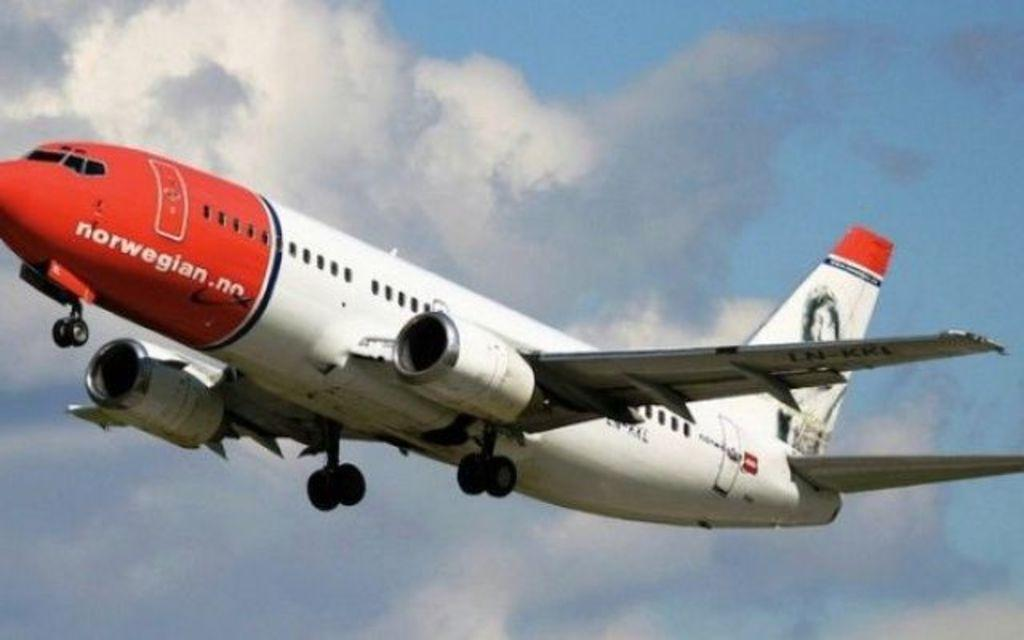<image>
Give a short and clear explanation of the subsequent image. A Norwegian plane with a red nose flies through the air. 